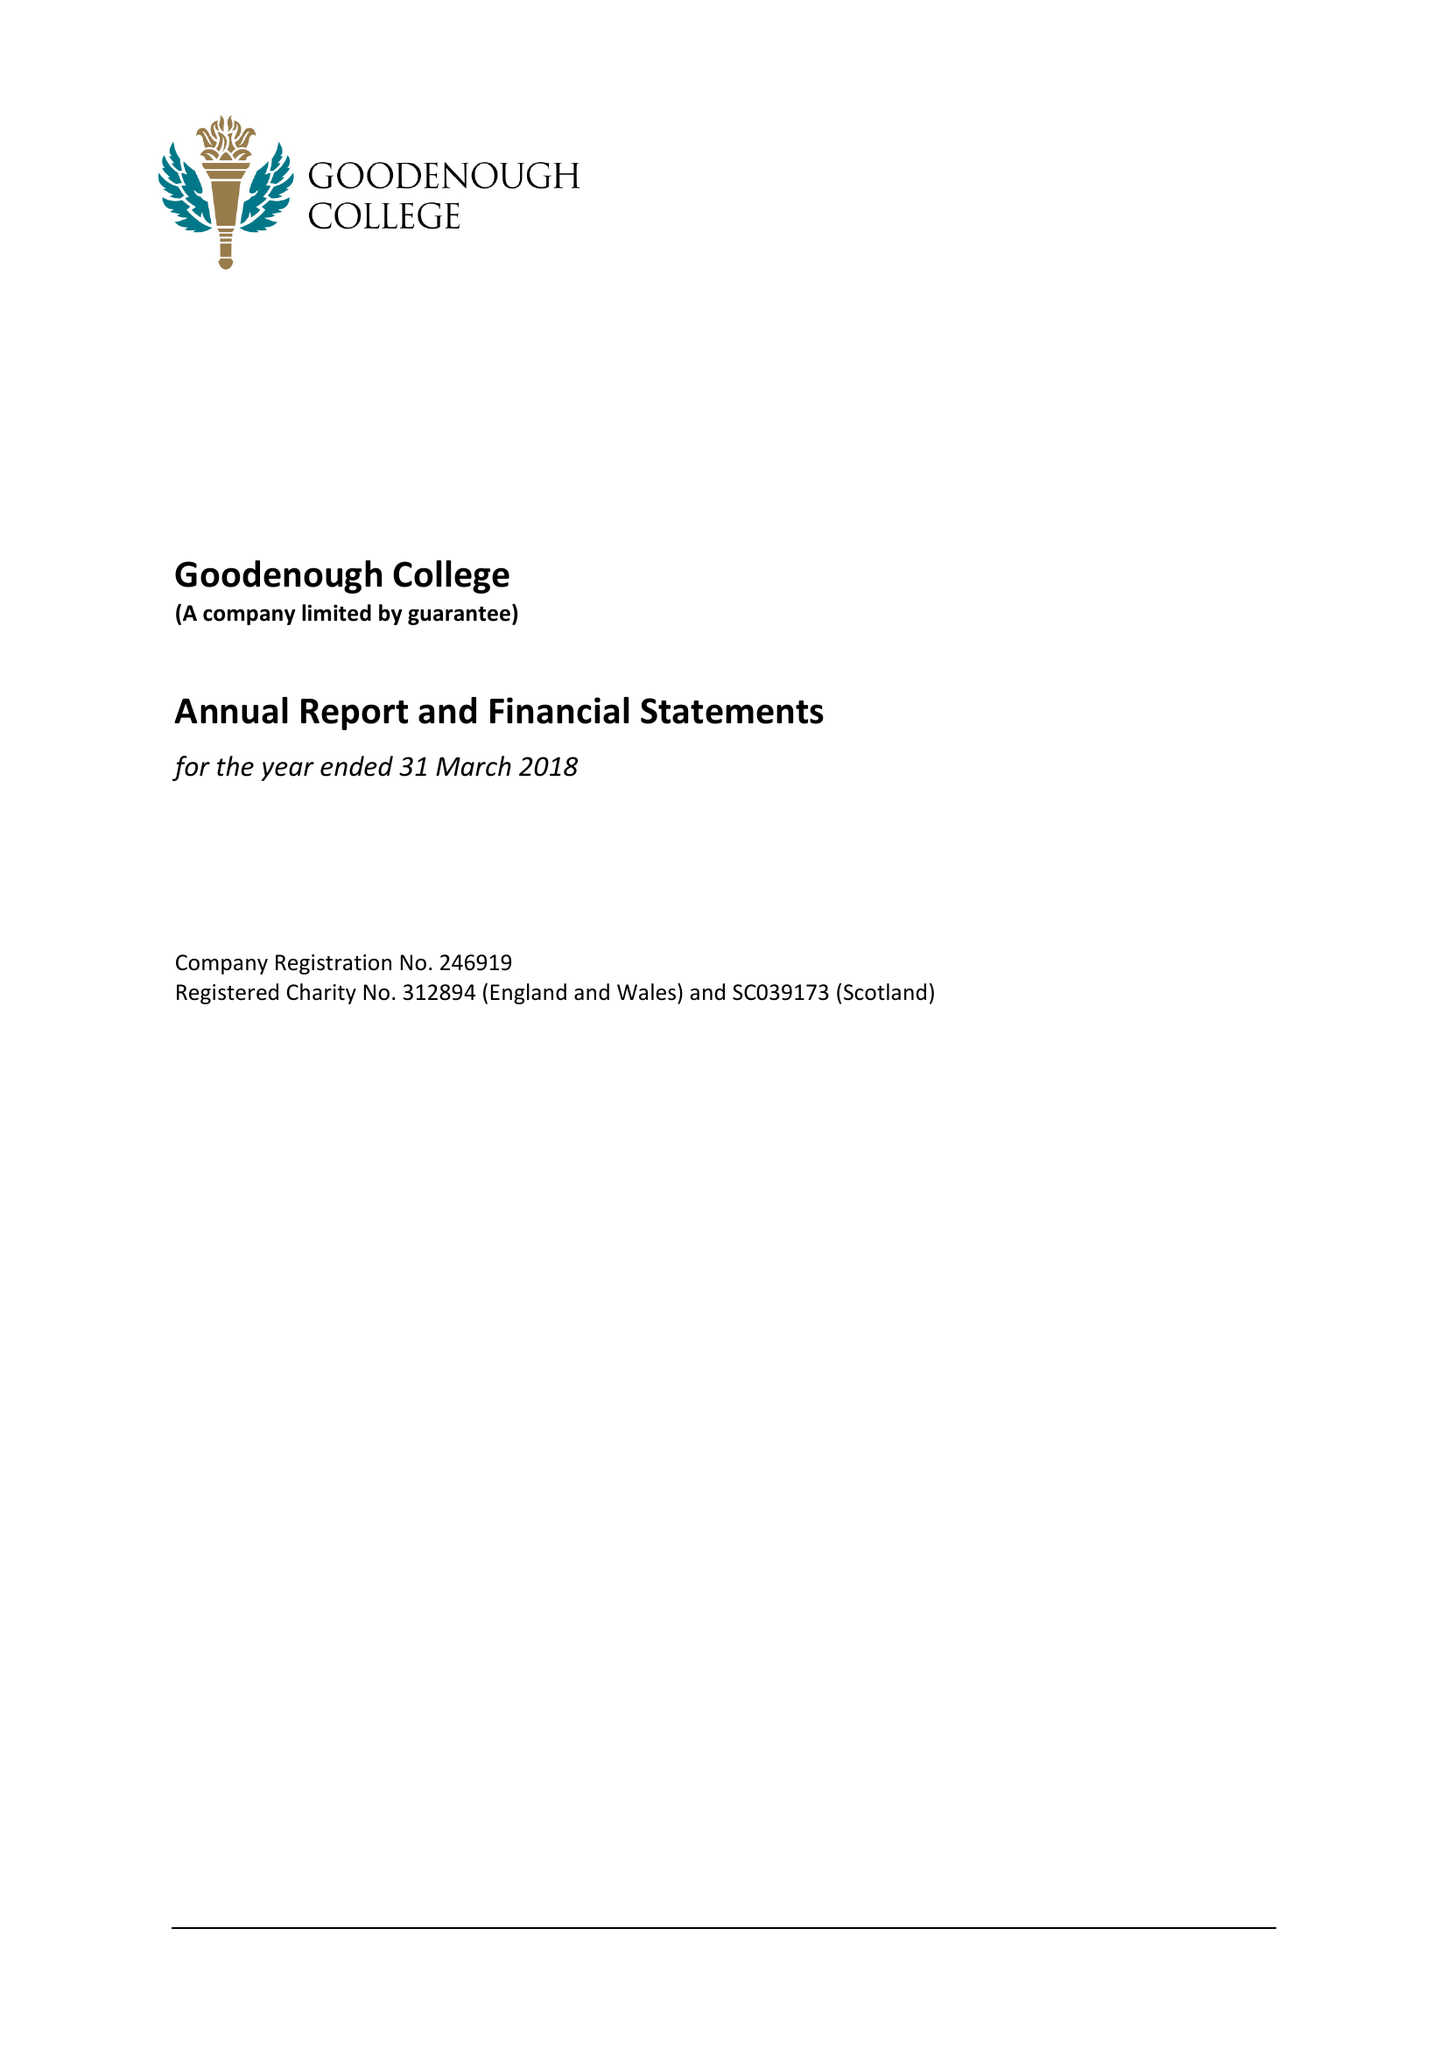What is the value for the address__postcode?
Answer the question using a single word or phrase. WC1N 2AB 